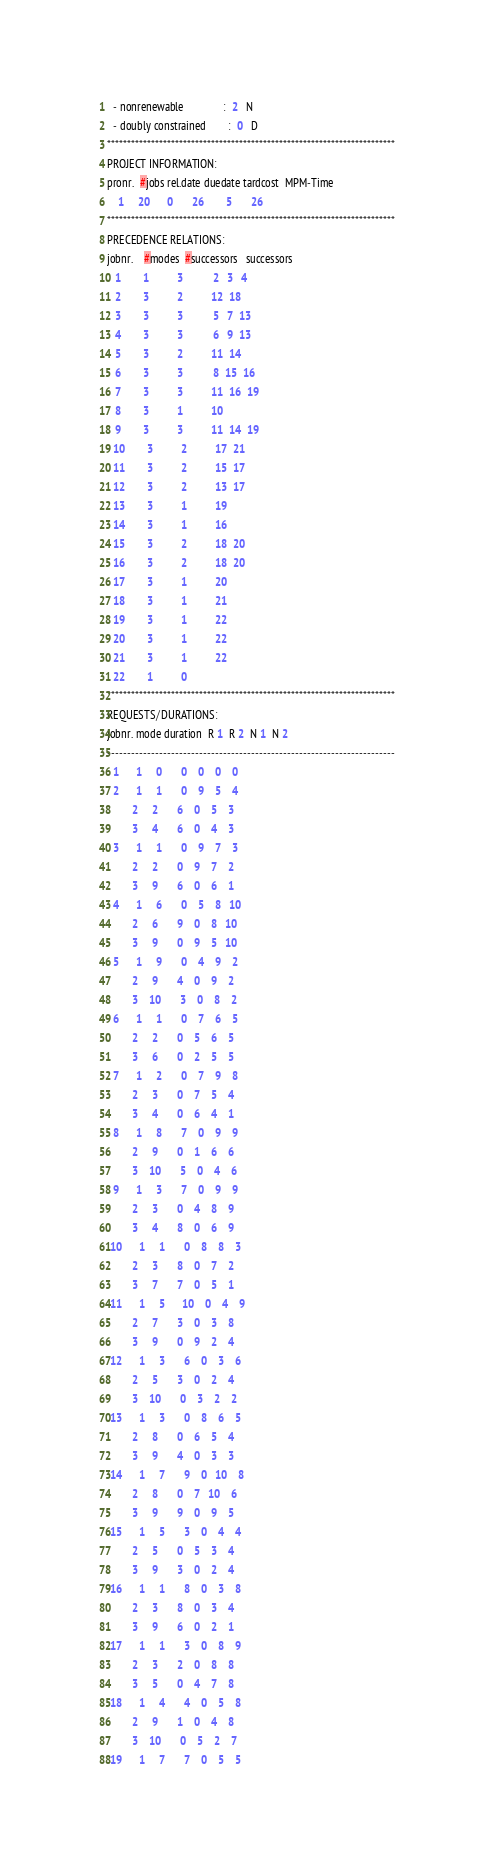Convert code to text. <code><loc_0><loc_0><loc_500><loc_500><_ObjectiveC_>  - nonrenewable              :  2   N
  - doubly constrained        :  0   D
************************************************************************
PROJECT INFORMATION:
pronr.  #jobs rel.date duedate tardcost  MPM-Time
    1     20      0       26        5       26
************************************************************************
PRECEDENCE RELATIONS:
jobnr.    #modes  #successors   successors
   1        1          3           2   3   4
   2        3          2          12  18
   3        3          3           5   7  13
   4        3          3           6   9  13
   5        3          2          11  14
   6        3          3           8  15  16
   7        3          3          11  16  19
   8        3          1          10
   9        3          3          11  14  19
  10        3          2          17  21
  11        3          2          15  17
  12        3          2          13  17
  13        3          1          19
  14        3          1          16
  15        3          2          18  20
  16        3          2          18  20
  17        3          1          20
  18        3          1          21
  19        3          1          22
  20        3          1          22
  21        3          1          22
  22        1          0        
************************************************************************
REQUESTS/DURATIONS:
jobnr. mode duration  R 1  R 2  N 1  N 2
------------------------------------------------------------------------
  1      1     0       0    0    0    0
  2      1     1       0    9    5    4
         2     2       6    0    5    3
         3     4       6    0    4    3
  3      1     1       0    9    7    3
         2     2       0    9    7    2
         3     9       6    0    6    1
  4      1     6       0    5    8   10
         2     6       9    0    8   10
         3     9       0    9    5   10
  5      1     9       0    4    9    2
         2     9       4    0    9    2
         3    10       3    0    8    2
  6      1     1       0    7    6    5
         2     2       0    5    6    5
         3     6       0    2    5    5
  7      1     2       0    7    9    8
         2     3       0    7    5    4
         3     4       0    6    4    1
  8      1     8       7    0    9    9
         2     9       0    1    6    6
         3    10       5    0    4    6
  9      1     3       7    0    9    9
         2     3       0    4    8    9
         3     4       8    0    6    9
 10      1     1       0    8    8    3
         2     3       8    0    7    2
         3     7       7    0    5    1
 11      1     5      10    0    4    9
         2     7       3    0    3    8
         3     9       0    9    2    4
 12      1     3       6    0    3    6
         2     5       3    0    2    4
         3    10       0    3    2    2
 13      1     3       0    8    6    5
         2     8       0    6    5    4
         3     9       4    0    3    3
 14      1     7       9    0   10    8
         2     8       0    7   10    6
         3     9       9    0    9    5
 15      1     5       3    0    4    4
         2     5       0    5    3    4
         3     9       3    0    2    4
 16      1     1       8    0    3    8
         2     3       8    0    3    4
         3     9       6    0    2    1
 17      1     1       3    0    8    9
         2     3       2    0    8    8
         3     5       0    4    7    8
 18      1     4       4    0    5    8
         2     9       1    0    4    8
         3    10       0    5    2    7
 19      1     7       7    0    5    5</code> 